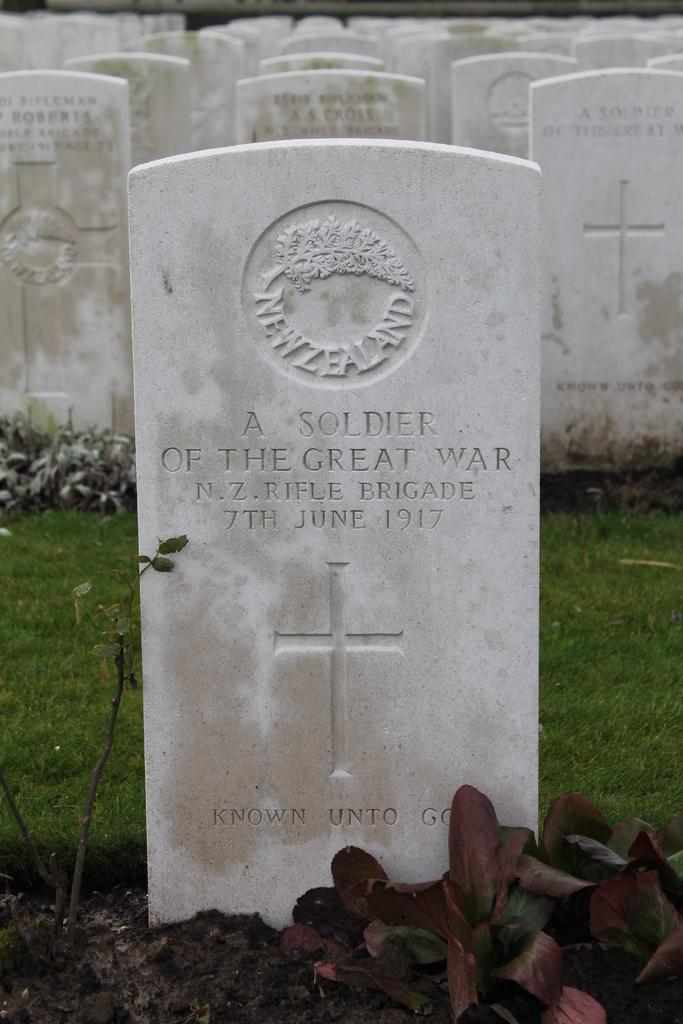What type of structures can be seen in the image? There are tombstones in the image. What type of vegetation is visible in the image? Grass and plants are visible in the image. Can you describe the argument taking place between the clouds in the image? There are no clouds present in the image, so there is no argument to describe. 